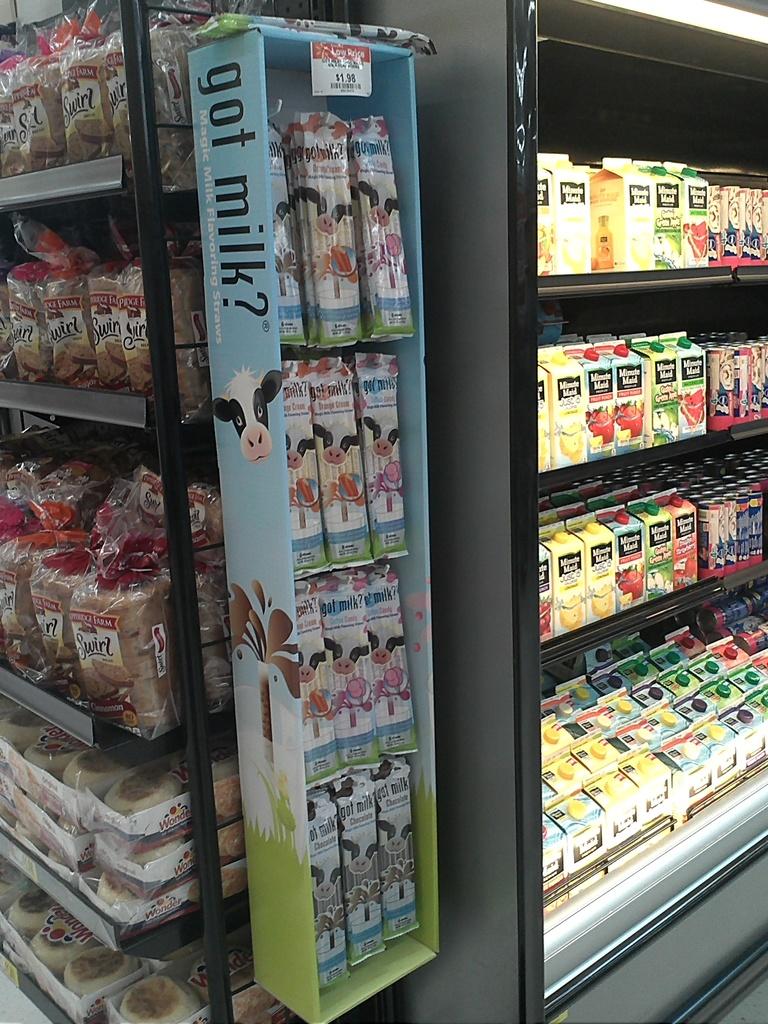What is the display say?
Offer a terse response. Got milk. This is grocery or restaurant?
Keep it short and to the point. Answering does not require reading text in the image. 